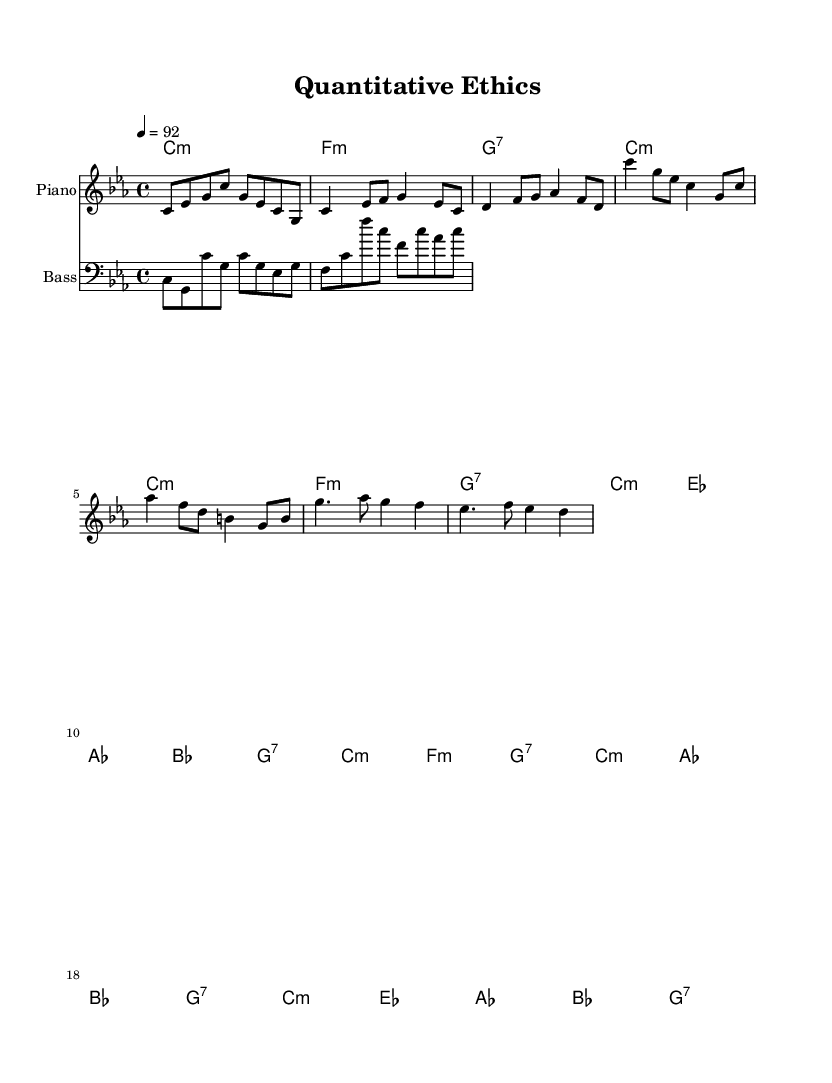What is the key signature of this music? The key signature is C minor, which includes three flats (B flat, E flat, A flat). This can be determined by looking at the key signature notation at the beginning of the score.
Answer: C minor What is the time signature of the piece? The time signature is 4/4, which indicates that there are four beats in each measure and the quarter note gets one beat. This is visible as the "4/4" notation at the beginning of the score.
Answer: 4/4 What is the tempo marking for this piece? The tempo marking is 92 beats per minute, indicated by "4 = 92" in the score, which shows how many beats occur in a minute.
Answer: 92 How many measures are there in the verse? There are four measures in the verse section, which can be counted by examining the notation between the double bars that indicate the start and end of this section.
Answer: 4 Which type of chords are predominantly used in the piece? The chords used predominantly in the piece are minor chords, as indicated by the notation "m" next to the chords in the harmonies section. This suggests a focus on C minor, F minor, and G7.
Answer: Minor What is the relationship between the bass and the harmonic structure? The bass line complements the harmonies by providing the root notes of the chords during specific measures, reinforcing the harmonic framework. This can be observed by matching the bass notes with the corresponding chords outlined above in the score.
Answer: Complementary How does the chorus differ from the verse in terms of harmonic progression? The chorus introduces additional harmony, following a similar structure but layering more complexity with more variations in chords, such as A flat and B flat. This could suggest a heightened emotional impact during the chorus, differentiating it from the simpler verse. Step by step, by analyzing and comparing the chord changes between the two sections, we can note the variances introduced in the chorus.
Answer: More complex 